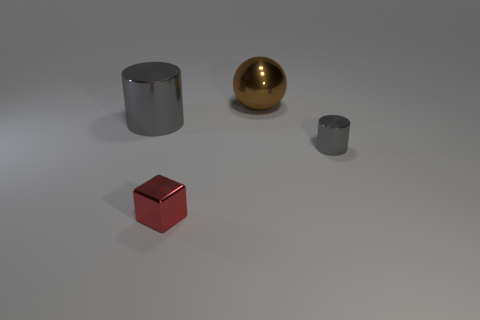Is the material of the gray cylinder that is to the left of the metallic sphere the same as the cylinder that is in front of the big metallic cylinder? yes 